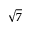Convert formula to latex. <formula><loc_0><loc_0><loc_500><loc_500>\sqrt { 7 }</formula> 